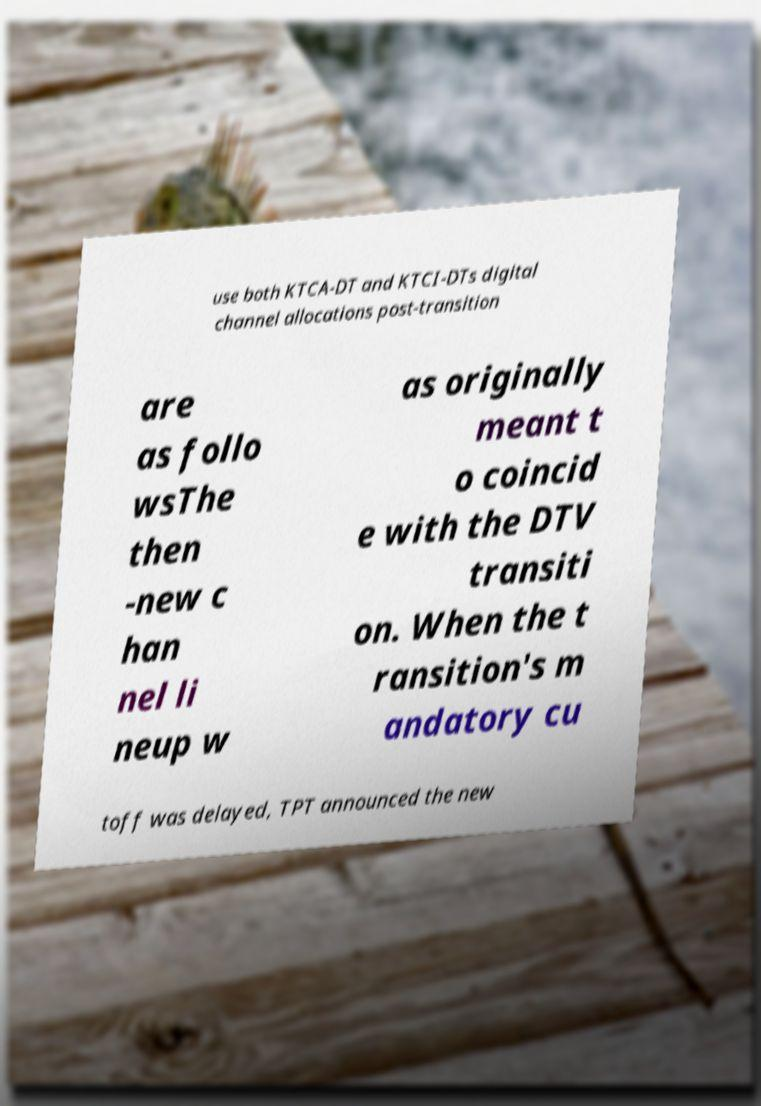Could you extract and type out the text from this image? use both KTCA-DT and KTCI-DTs digital channel allocations post-transition are as follo wsThe then -new c han nel li neup w as originally meant t o coincid e with the DTV transiti on. When the t ransition's m andatory cu toff was delayed, TPT announced the new 